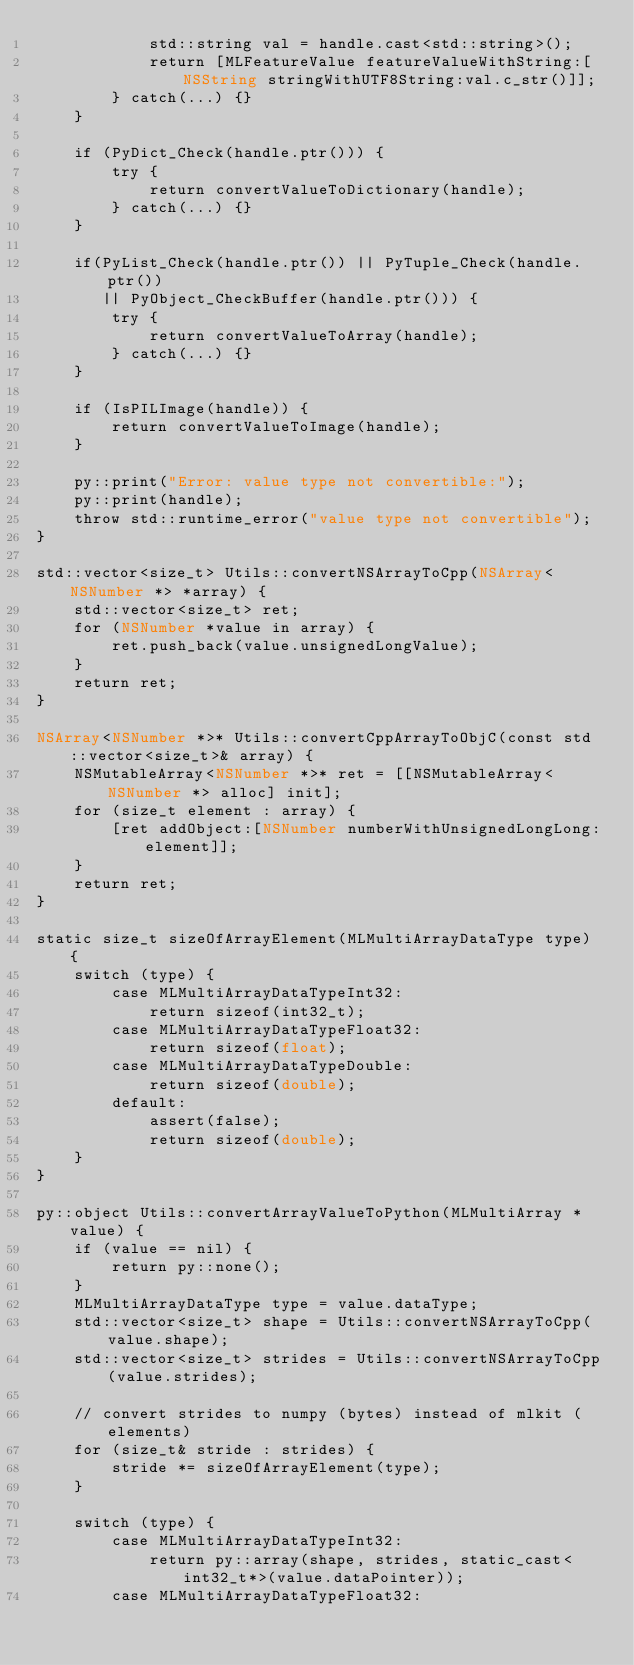Convert code to text. <code><loc_0><loc_0><loc_500><loc_500><_ObjectiveC_>            std::string val = handle.cast<std::string>();
            return [MLFeatureValue featureValueWithString:[NSString stringWithUTF8String:val.c_str()]];
        } catch(...) {}
    }

    if (PyDict_Check(handle.ptr())) {
        try {
            return convertValueToDictionary(handle);
        } catch(...) {}
    }

    if(PyList_Check(handle.ptr()) || PyTuple_Check(handle.ptr())
       || PyObject_CheckBuffer(handle.ptr())) {
        try {
            return convertValueToArray(handle);
        } catch(...) {}
    }

    if (IsPILImage(handle)) {
        return convertValueToImage(handle);
    }

    py::print("Error: value type not convertible:");
    py::print(handle);
    throw std::runtime_error("value type not convertible");
}

std::vector<size_t> Utils::convertNSArrayToCpp(NSArray<NSNumber *> *array) {
    std::vector<size_t> ret;
    for (NSNumber *value in array) {
        ret.push_back(value.unsignedLongValue);
    }
    return ret;
}

NSArray<NSNumber *>* Utils::convertCppArrayToObjC(const std::vector<size_t>& array) {
    NSMutableArray<NSNumber *>* ret = [[NSMutableArray<NSNumber *> alloc] init];
    for (size_t element : array) {
        [ret addObject:[NSNumber numberWithUnsignedLongLong:element]];
    }
    return ret;
}

static size_t sizeOfArrayElement(MLMultiArrayDataType type) {
    switch (type) {
        case MLMultiArrayDataTypeInt32:
            return sizeof(int32_t);
        case MLMultiArrayDataTypeFloat32:
            return sizeof(float);
        case MLMultiArrayDataTypeDouble:
            return sizeof(double);
        default:
            assert(false);
            return sizeof(double);
    }
}

py::object Utils::convertArrayValueToPython(MLMultiArray *value) {
    if (value == nil) {
        return py::none();
    }
    MLMultiArrayDataType type = value.dataType;
    std::vector<size_t> shape = Utils::convertNSArrayToCpp(value.shape);
    std::vector<size_t> strides = Utils::convertNSArrayToCpp(value.strides);

    // convert strides to numpy (bytes) instead of mlkit (elements)
    for (size_t& stride : strides) {
        stride *= sizeOfArrayElement(type);
    }

    switch (type) {
        case MLMultiArrayDataTypeInt32:
            return py::array(shape, strides, static_cast<int32_t*>(value.dataPointer));
        case MLMultiArrayDataTypeFloat32:</code> 